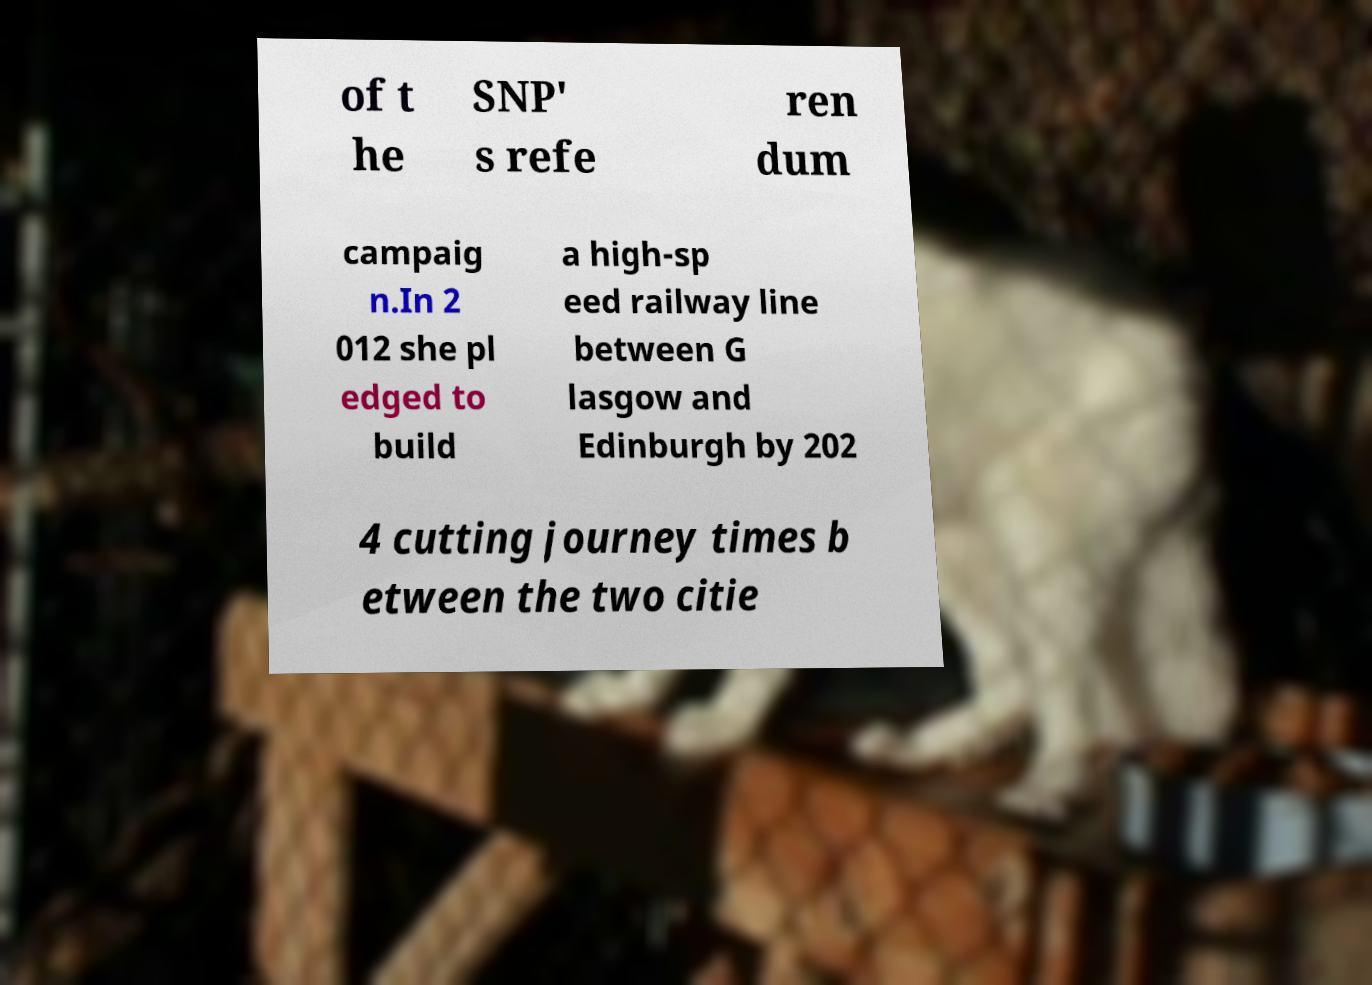Can you accurately transcribe the text from the provided image for me? of t he SNP' s refe ren dum campaig n.In 2 012 she pl edged to build a high-sp eed railway line between G lasgow and Edinburgh by 202 4 cutting journey times b etween the two citie 